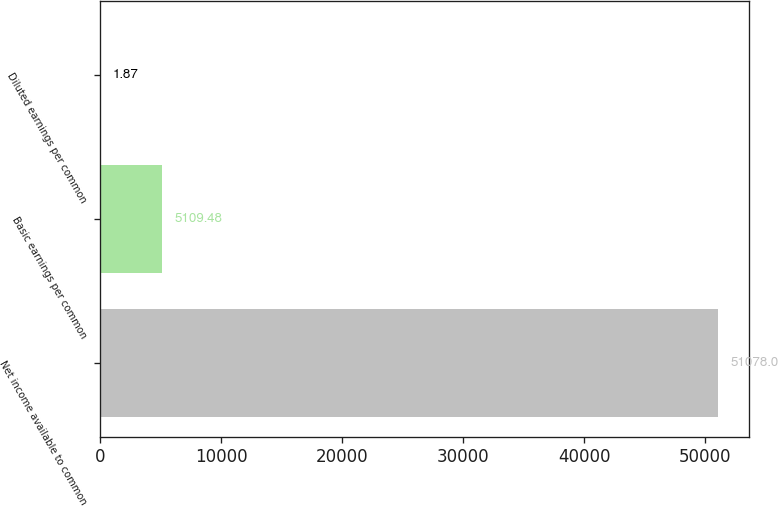<chart> <loc_0><loc_0><loc_500><loc_500><bar_chart><fcel>Net income available to common<fcel>Basic earnings per common<fcel>Diluted earnings per common<nl><fcel>51078<fcel>5109.48<fcel>1.87<nl></chart> 